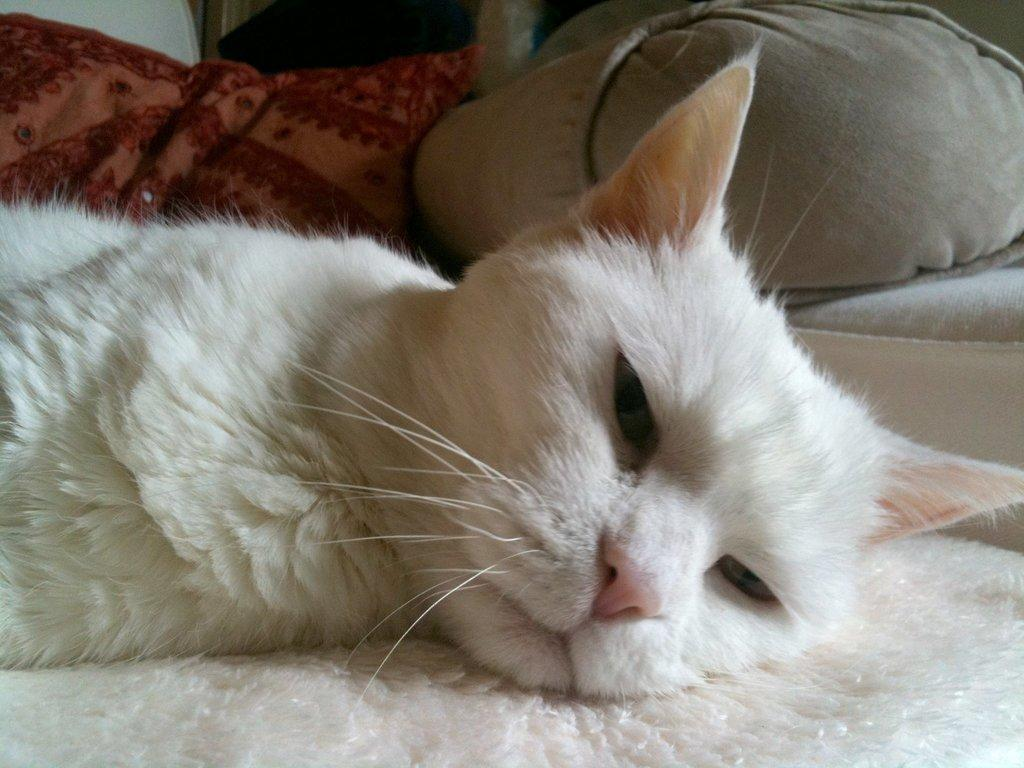What type of animal is in the image? There is a cat in the image. Where is the cat located? The cat is on a bed. What color is the bed? The bed is white. What advice does the cat give to the person in the image? There is no indication in the image that the cat is giving advice to anyone. 